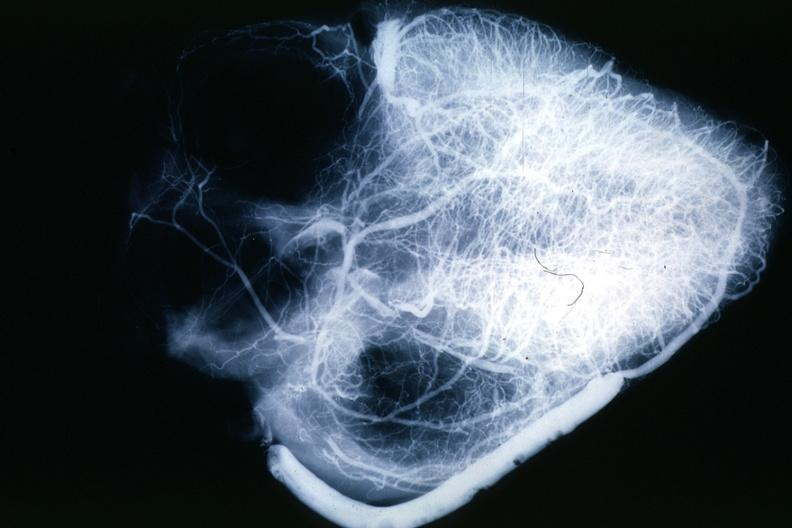s cardiovascular present?
Answer the question using a single word or phrase. Yes 